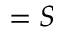<formula> <loc_0><loc_0><loc_500><loc_500>= S</formula> 